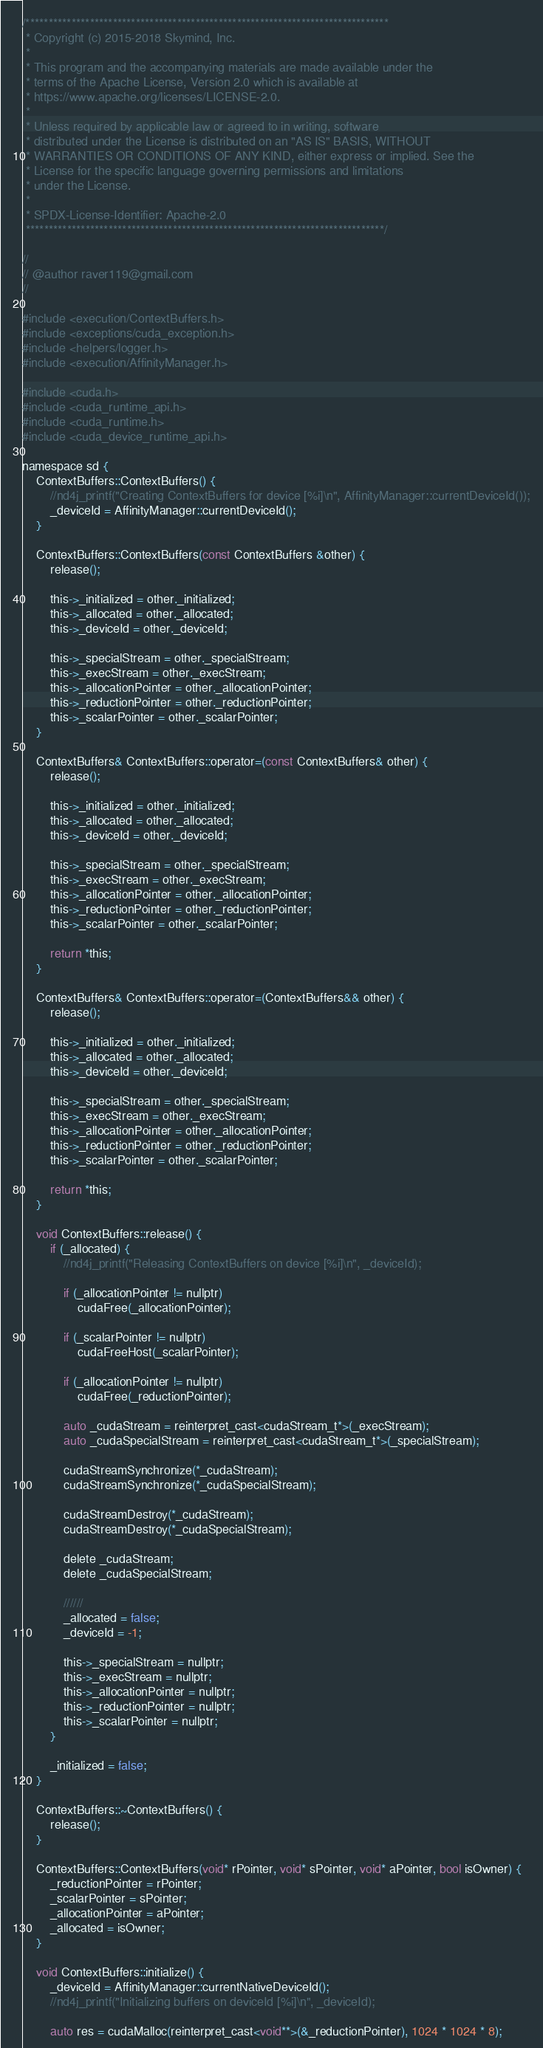Convert code to text. <code><loc_0><loc_0><loc_500><loc_500><_Cuda_>/*******************************************************************************
 * Copyright (c) 2015-2018 Skymind, Inc.
 *
 * This program and the accompanying materials are made available under the
 * terms of the Apache License, Version 2.0 which is available at
 * https://www.apache.org/licenses/LICENSE-2.0.
 *
 * Unless required by applicable law or agreed to in writing, software
 * distributed under the License is distributed on an "AS IS" BASIS, WITHOUT
 * WARRANTIES OR CONDITIONS OF ANY KIND, either express or implied. See the
 * License for the specific language governing permissions and limitations
 * under the License.
 *
 * SPDX-License-Identifier: Apache-2.0
 ******************************************************************************/

//
// @author raver119@gmail.com
//

#include <execution/ContextBuffers.h>
#include <exceptions/cuda_exception.h>
#include <helpers/logger.h>
#include <execution/AffinityManager.h>

#include <cuda.h>
#include <cuda_runtime_api.h>
#include <cuda_runtime.h>
#include <cuda_device_runtime_api.h>

namespace sd {
    ContextBuffers::ContextBuffers() {
        //nd4j_printf("Creating ContextBuffers for device [%i]\n", AffinityManager::currentDeviceId());
        _deviceId = AffinityManager::currentDeviceId();
    }

    ContextBuffers::ContextBuffers(const ContextBuffers &other) {
        release();

        this->_initialized = other._initialized;
        this->_allocated = other._allocated;
        this->_deviceId = other._deviceId;

        this->_specialStream = other._specialStream;
        this->_execStream = other._execStream;
        this->_allocationPointer = other._allocationPointer;
        this->_reductionPointer = other._reductionPointer;
        this->_scalarPointer = other._scalarPointer;
    }

    ContextBuffers& ContextBuffers::operator=(const ContextBuffers& other) {
        release();

        this->_initialized = other._initialized;
        this->_allocated = other._allocated;
        this->_deviceId = other._deviceId;

        this->_specialStream = other._specialStream;
        this->_execStream = other._execStream;
        this->_allocationPointer = other._allocationPointer;
        this->_reductionPointer = other._reductionPointer;
        this->_scalarPointer = other._scalarPointer;

        return *this;
    }

    ContextBuffers& ContextBuffers::operator=(ContextBuffers&& other) {
        release();

        this->_initialized = other._initialized;
        this->_allocated = other._allocated;
        this->_deviceId = other._deviceId;

        this->_specialStream = other._specialStream;
        this->_execStream = other._execStream;
        this->_allocationPointer = other._allocationPointer;
        this->_reductionPointer = other._reductionPointer;
        this->_scalarPointer = other._scalarPointer;

        return *this;
    }

    void ContextBuffers::release() {
        if (_allocated) {
            //nd4j_printf("Releasing ContextBuffers on device [%i]\n", _deviceId);

            if (_allocationPointer != nullptr)
                cudaFree(_allocationPointer);

            if (_scalarPointer != nullptr)
                cudaFreeHost(_scalarPointer);

            if (_allocationPointer != nullptr)
                cudaFree(_reductionPointer);

            auto _cudaStream = reinterpret_cast<cudaStream_t*>(_execStream);
            auto _cudaSpecialStream = reinterpret_cast<cudaStream_t*>(_specialStream);

            cudaStreamSynchronize(*_cudaStream);
            cudaStreamSynchronize(*_cudaSpecialStream);

            cudaStreamDestroy(*_cudaStream);
            cudaStreamDestroy(*_cudaSpecialStream);

            delete _cudaStream;
            delete _cudaSpecialStream;

            //////
            _allocated = false;
            _deviceId = -1;

            this->_specialStream = nullptr;
            this->_execStream = nullptr;
            this->_allocationPointer = nullptr;
            this->_reductionPointer = nullptr;
            this->_scalarPointer = nullptr;
        }

        _initialized = false;
    }

    ContextBuffers::~ContextBuffers() {
        release();
    }

    ContextBuffers::ContextBuffers(void* rPointer, void* sPointer, void* aPointer, bool isOwner) {
        _reductionPointer = rPointer;
        _scalarPointer = sPointer;
        _allocationPointer = aPointer;
        _allocated = isOwner;
    }

    void ContextBuffers::initialize() {
        _deviceId = AffinityManager::currentNativeDeviceId();
        //nd4j_printf("Initializing buffers on deviceId [%i]\n", _deviceId);

        auto res = cudaMalloc(reinterpret_cast<void**>(&_reductionPointer), 1024 * 1024 * 8);</code> 